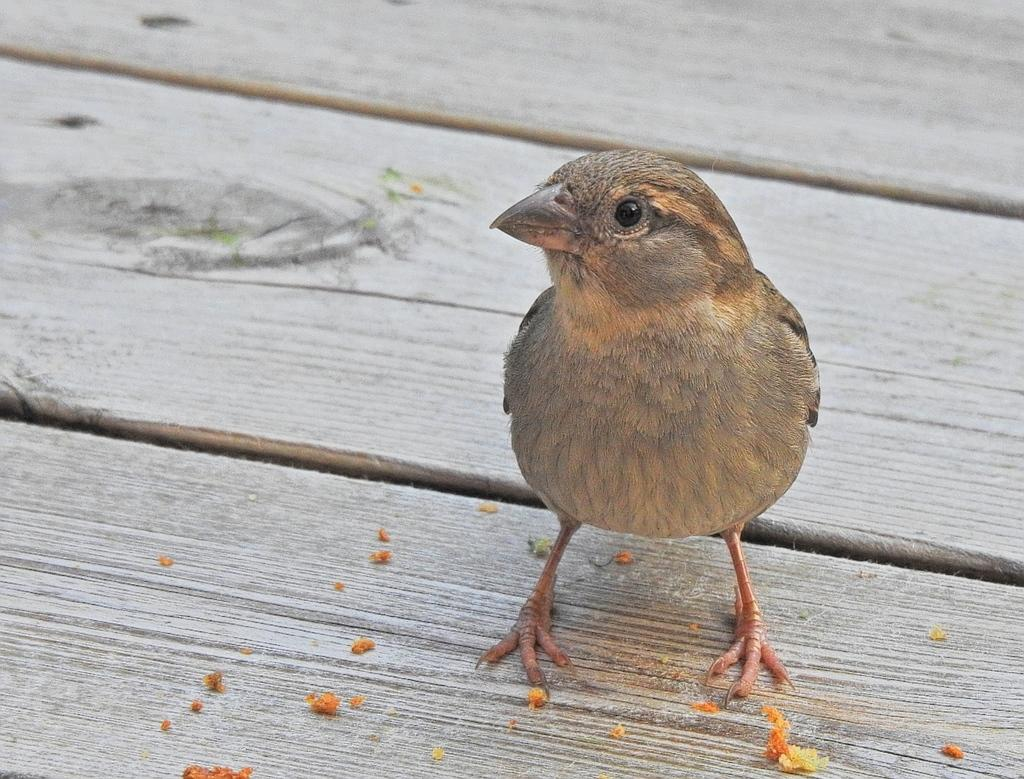What type of animal is in the image? There is a bird in the image. Where is the bird located? The bird is on a wooden table. What color is the bird? The bird is brown in color. What direction is the bird facing on the scale in the image? There is no scale present in the image, and the bird is not facing any particular direction. 